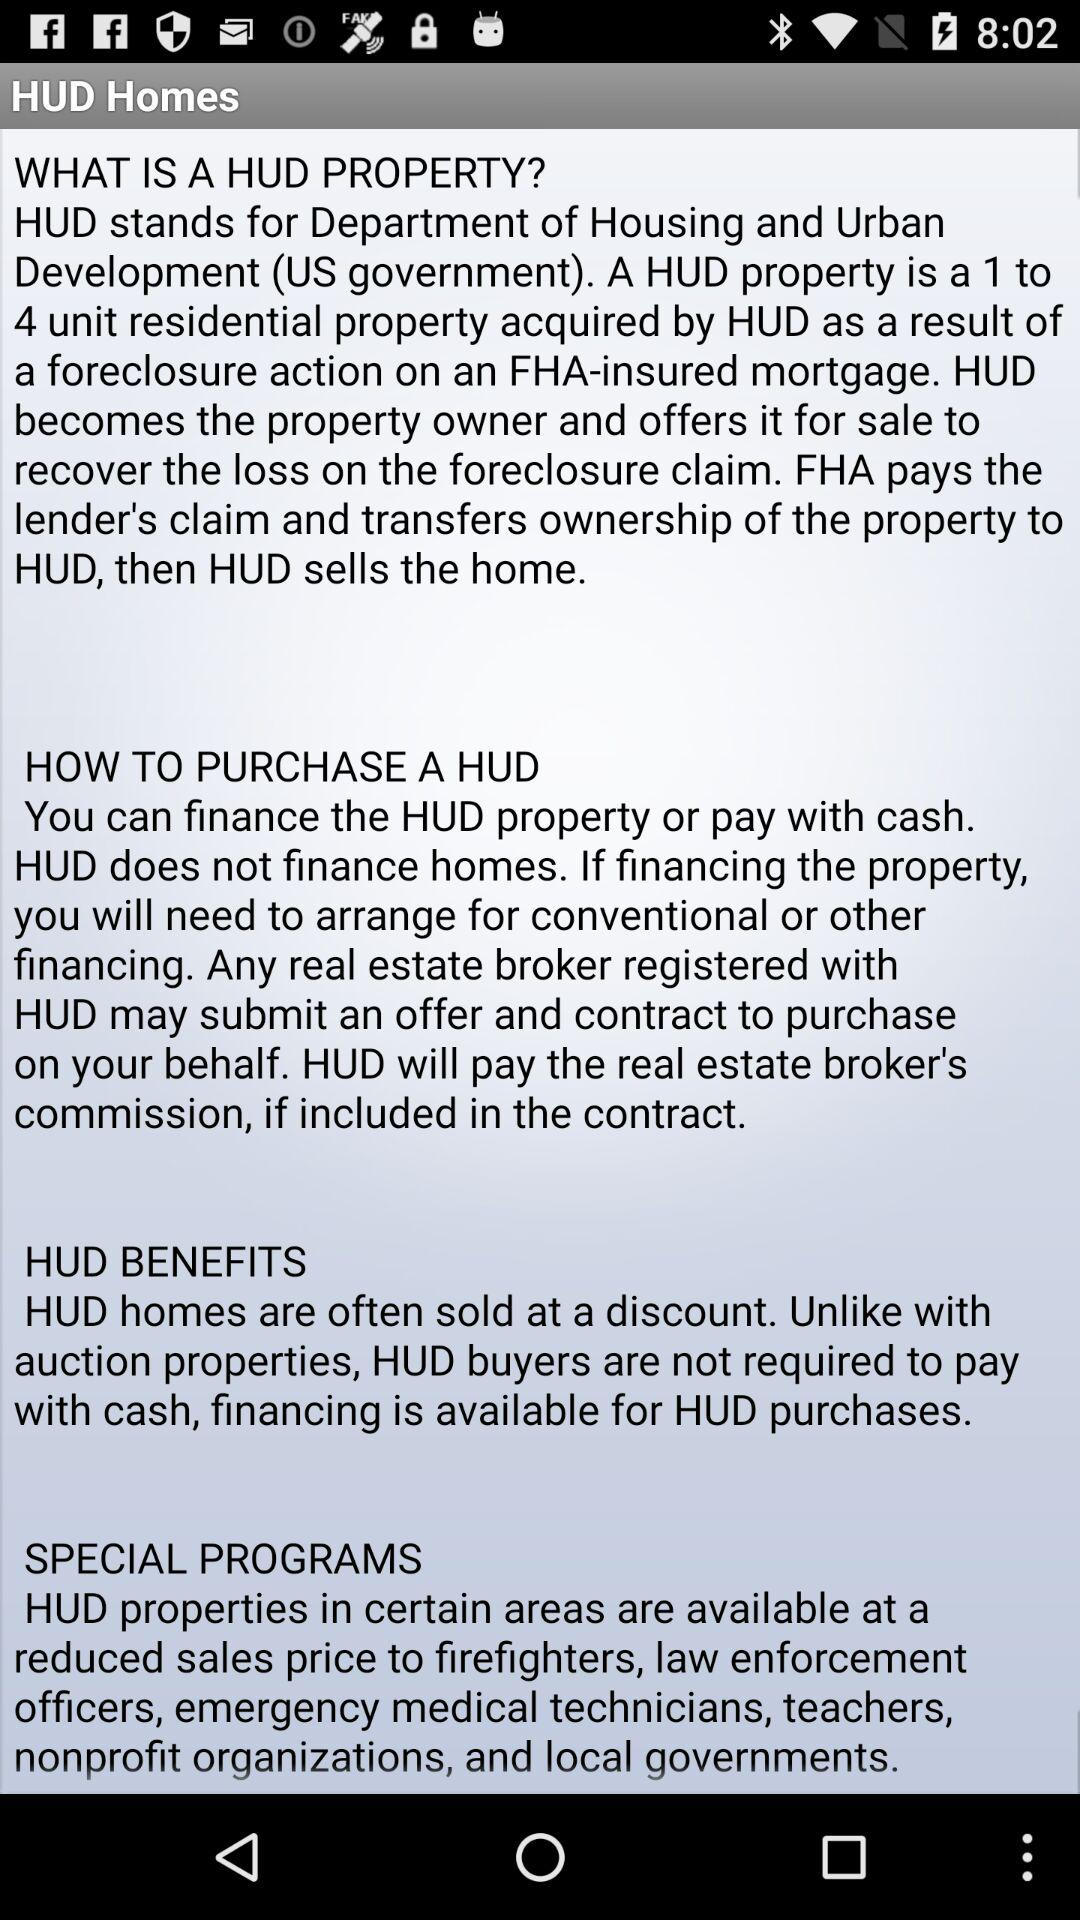What is the URL for the HUD website?
When the provided information is insufficient, respond with <no answer>. <no answer> 